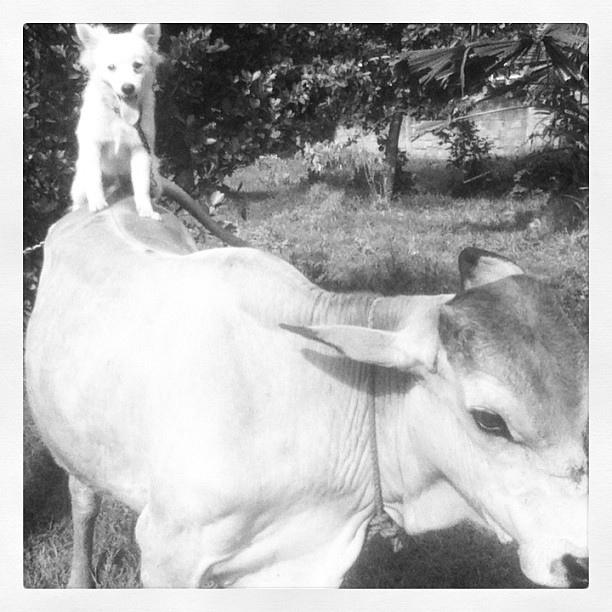What color is this animal?
Write a very short answer. White. What is the dog on?
Be succinct. Cow. Is the dog sad?
Concise answer only. No. 